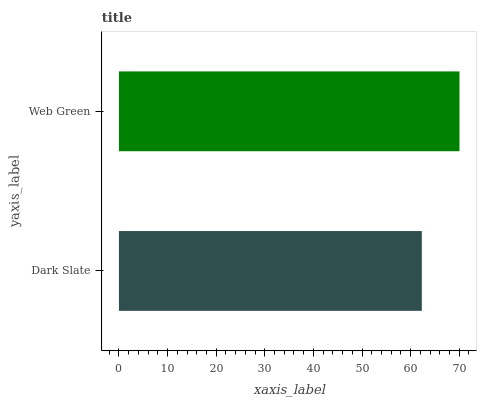Is Dark Slate the minimum?
Answer yes or no. Yes. Is Web Green the maximum?
Answer yes or no. Yes. Is Web Green the minimum?
Answer yes or no. No. Is Web Green greater than Dark Slate?
Answer yes or no. Yes. Is Dark Slate less than Web Green?
Answer yes or no. Yes. Is Dark Slate greater than Web Green?
Answer yes or no. No. Is Web Green less than Dark Slate?
Answer yes or no. No. Is Web Green the high median?
Answer yes or no. Yes. Is Dark Slate the low median?
Answer yes or no. Yes. Is Dark Slate the high median?
Answer yes or no. No. Is Web Green the low median?
Answer yes or no. No. 